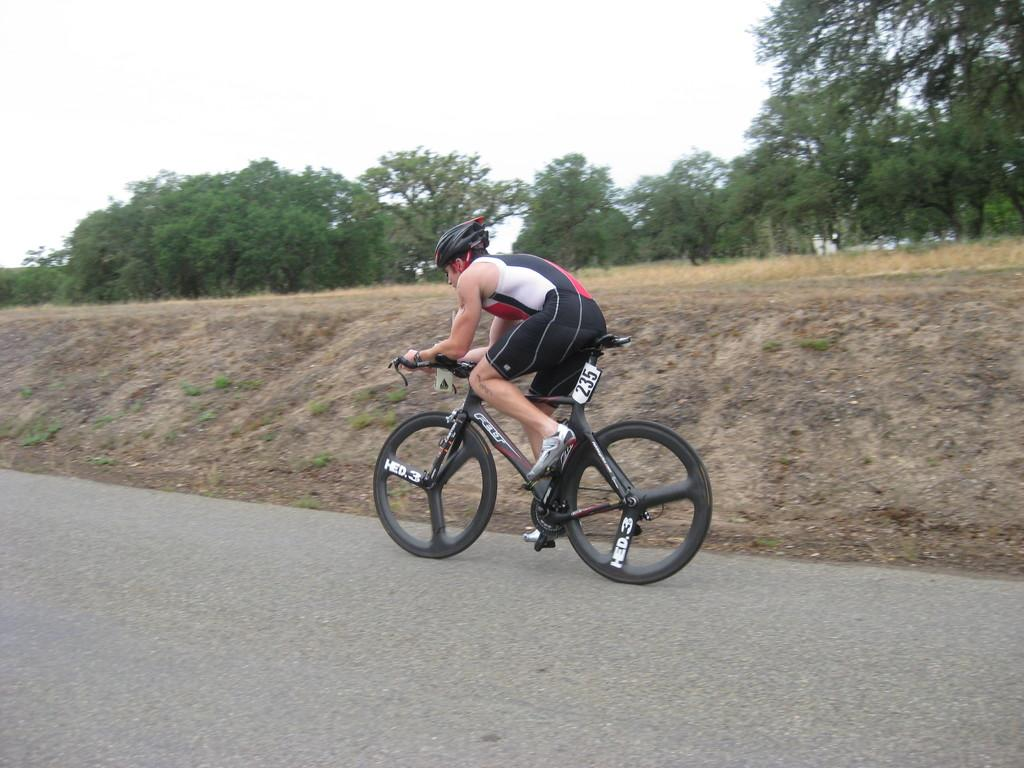Who or what is the main subject in the image? There is a person in the image. What is the person wearing? The person is wearing a helmet. What activity is the person engaged in? The person is riding a bicycle. What type of natural environment is visible in the image? There are trees and grass on the ground in the image. Can you see any apples on the trees in the image? There is no mention of apples or any fruit on the trees in the image. Is there a robin perched on the person's shoulder in the image? There is no mention of a robin or any bird in the image. 